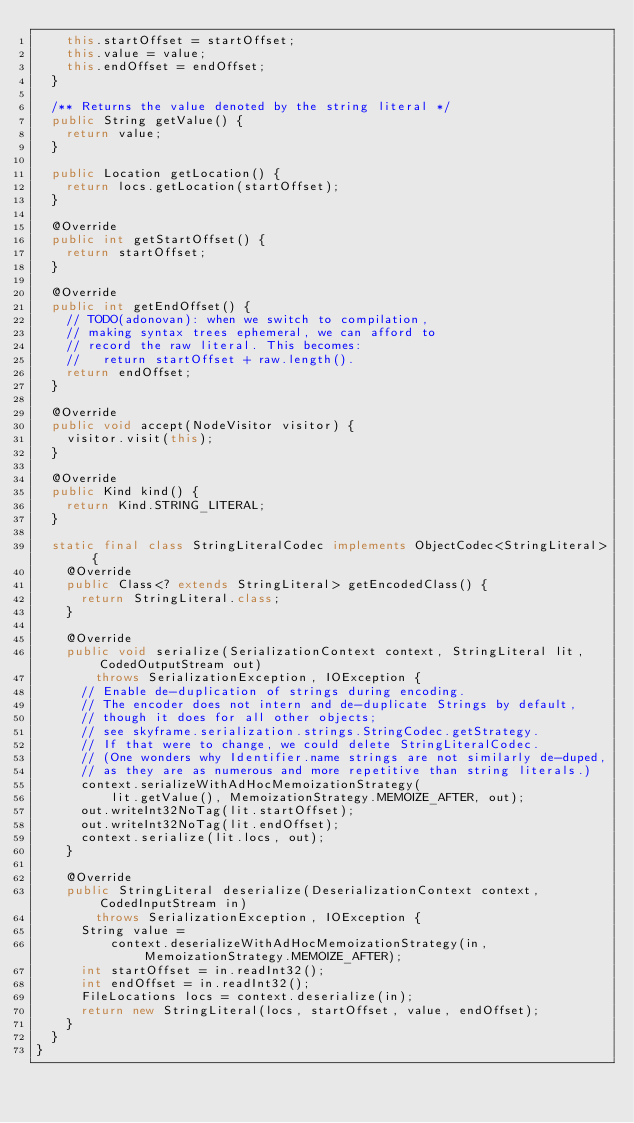<code> <loc_0><loc_0><loc_500><loc_500><_Java_>    this.startOffset = startOffset;
    this.value = value;
    this.endOffset = endOffset;
  }

  /** Returns the value denoted by the string literal */
  public String getValue() {
    return value;
  }

  public Location getLocation() {
    return locs.getLocation(startOffset);
  }

  @Override
  public int getStartOffset() {
    return startOffset;
  }

  @Override
  public int getEndOffset() {
    // TODO(adonovan): when we switch to compilation,
    // making syntax trees ephemeral, we can afford to
    // record the raw literal. This becomes:
    //   return startOffset + raw.length().
    return endOffset;
  }

  @Override
  public void accept(NodeVisitor visitor) {
    visitor.visit(this);
  }

  @Override
  public Kind kind() {
    return Kind.STRING_LITERAL;
  }

  static final class StringLiteralCodec implements ObjectCodec<StringLiteral> {
    @Override
    public Class<? extends StringLiteral> getEncodedClass() {
      return StringLiteral.class;
    }

    @Override
    public void serialize(SerializationContext context, StringLiteral lit, CodedOutputStream out)
        throws SerializationException, IOException {
      // Enable de-duplication of strings during encoding.
      // The encoder does not intern and de-duplicate Strings by default,
      // though it does for all other objects;
      // see skyframe.serialization.strings.StringCodec.getStrategy.
      // If that were to change, we could delete StringLiteralCodec.
      // (One wonders why Identifier.name strings are not similarly de-duped,
      // as they are as numerous and more repetitive than string literals.)
      context.serializeWithAdHocMemoizationStrategy(
          lit.getValue(), MemoizationStrategy.MEMOIZE_AFTER, out);
      out.writeInt32NoTag(lit.startOffset);
      out.writeInt32NoTag(lit.endOffset);
      context.serialize(lit.locs, out);
    }

    @Override
    public StringLiteral deserialize(DeserializationContext context, CodedInputStream in)
        throws SerializationException, IOException {
      String value =
          context.deserializeWithAdHocMemoizationStrategy(in, MemoizationStrategy.MEMOIZE_AFTER);
      int startOffset = in.readInt32();
      int endOffset = in.readInt32();
      FileLocations locs = context.deserialize(in);
      return new StringLiteral(locs, startOffset, value, endOffset);
    }
  }
}
</code> 